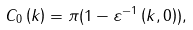<formula> <loc_0><loc_0><loc_500><loc_500>C _ { 0 } \left ( k \right ) = \pi ( 1 - \varepsilon ^ { - 1 } \left ( k , 0 \right ) ) ,</formula> 